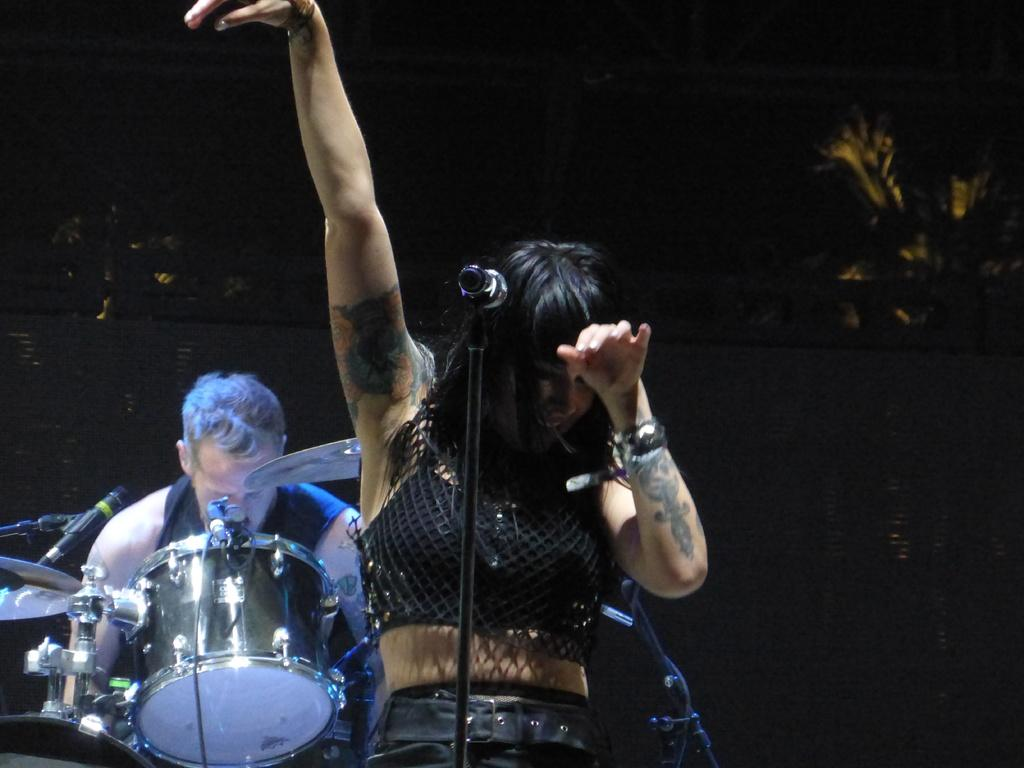Who is the main subject in the image? There is a woman in the image. What object is in front of the woman? There is a microphone in front of the woman. What other activity is happening in the image? There is a person playing drums in the image. What type of train can be seen in the image? There is no train present in the image. 